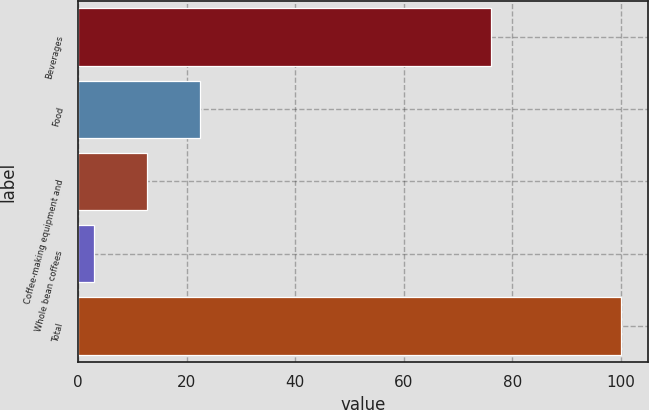Convert chart to OTSL. <chart><loc_0><loc_0><loc_500><loc_500><bar_chart><fcel>Beverages<fcel>Food<fcel>Coffee-making equipment and<fcel>Whole bean coffees<fcel>Total<nl><fcel>76<fcel>22.4<fcel>12.7<fcel>3<fcel>100<nl></chart> 